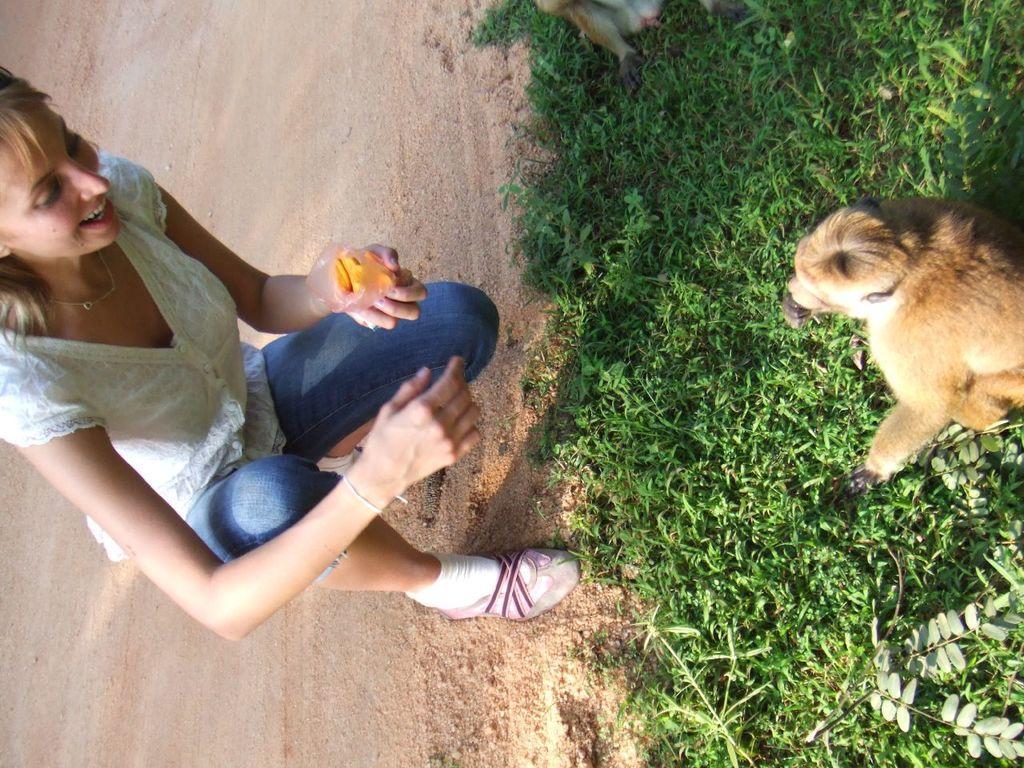Can you describe this image briefly? In this image we can see a lady and she is holding an object in her hand. There are few animals in the image. There is a grassy land in the image. There is a plant in the image. 